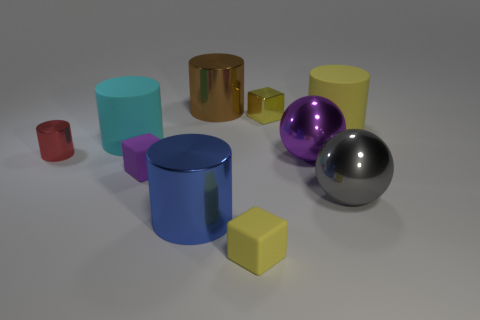Subtract 2 cylinders. How many cylinders are left? 3 Subtract all purple cylinders. Subtract all purple cubes. How many cylinders are left? 5 Subtract all blocks. How many objects are left? 7 Subtract 0 yellow spheres. How many objects are left? 10 Subtract all yellow cubes. Subtract all large yellow matte cylinders. How many objects are left? 7 Add 5 purple objects. How many purple objects are left? 7 Add 3 red cylinders. How many red cylinders exist? 4 